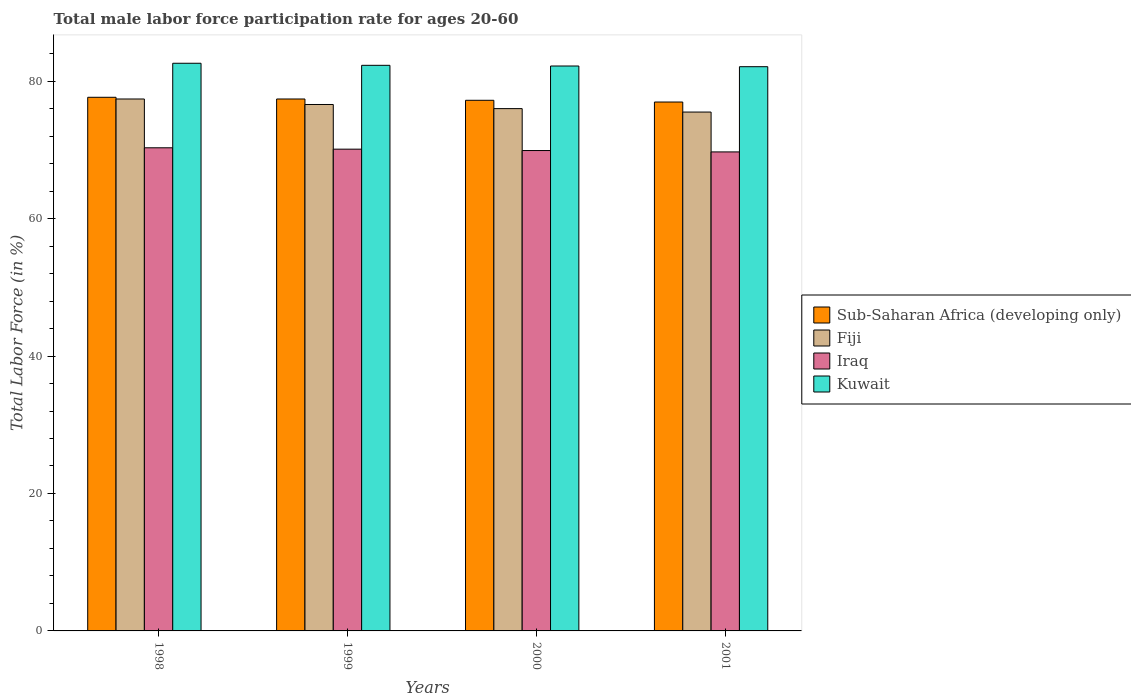How many groups of bars are there?
Your answer should be very brief. 4. How many bars are there on the 4th tick from the left?
Provide a short and direct response. 4. What is the male labor force participation rate in Kuwait in 1999?
Offer a terse response. 82.3. Across all years, what is the maximum male labor force participation rate in Iraq?
Offer a terse response. 70.3. Across all years, what is the minimum male labor force participation rate in Iraq?
Keep it short and to the point. 69.7. In which year was the male labor force participation rate in Fiji maximum?
Offer a terse response. 1998. In which year was the male labor force participation rate in Kuwait minimum?
Your response must be concise. 2001. What is the total male labor force participation rate in Kuwait in the graph?
Ensure brevity in your answer.  329.2. What is the difference between the male labor force participation rate in Iraq in 1998 and that in 1999?
Give a very brief answer. 0.2. What is the difference between the male labor force participation rate in Iraq in 2000 and the male labor force participation rate in Fiji in 1998?
Your answer should be very brief. -7.5. What is the average male labor force participation rate in Sub-Saharan Africa (developing only) per year?
Provide a succinct answer. 77.31. In the year 1998, what is the difference between the male labor force participation rate in Sub-Saharan Africa (developing only) and male labor force participation rate in Kuwait?
Your answer should be compact. -4.95. What is the ratio of the male labor force participation rate in Fiji in 1999 to that in 2001?
Your answer should be compact. 1.01. Is the male labor force participation rate in Fiji in 1999 less than that in 2001?
Your answer should be very brief. No. What is the difference between the highest and the second highest male labor force participation rate in Sub-Saharan Africa (developing only)?
Ensure brevity in your answer.  0.25. What is the difference between the highest and the lowest male labor force participation rate in Fiji?
Your answer should be compact. 1.9. Is the sum of the male labor force participation rate in Iraq in 2000 and 2001 greater than the maximum male labor force participation rate in Fiji across all years?
Your response must be concise. Yes. What does the 2nd bar from the left in 2001 represents?
Offer a very short reply. Fiji. What does the 2nd bar from the right in 2001 represents?
Ensure brevity in your answer.  Iraq. How many bars are there?
Provide a short and direct response. 16. What is the difference between two consecutive major ticks on the Y-axis?
Your answer should be compact. 20. Does the graph contain any zero values?
Provide a short and direct response. No. Does the graph contain grids?
Make the answer very short. No. Where does the legend appear in the graph?
Make the answer very short. Center right. How are the legend labels stacked?
Offer a very short reply. Vertical. What is the title of the graph?
Offer a terse response. Total male labor force participation rate for ages 20-60. Does "Caribbean small states" appear as one of the legend labels in the graph?
Your answer should be compact. No. What is the label or title of the X-axis?
Make the answer very short. Years. What is the label or title of the Y-axis?
Provide a short and direct response. Total Labor Force (in %). What is the Total Labor Force (in %) in Sub-Saharan Africa (developing only) in 1998?
Offer a terse response. 77.65. What is the Total Labor Force (in %) of Fiji in 1998?
Provide a short and direct response. 77.4. What is the Total Labor Force (in %) of Iraq in 1998?
Provide a short and direct response. 70.3. What is the Total Labor Force (in %) of Kuwait in 1998?
Your answer should be compact. 82.6. What is the Total Labor Force (in %) of Sub-Saharan Africa (developing only) in 1999?
Provide a short and direct response. 77.4. What is the Total Labor Force (in %) of Fiji in 1999?
Provide a succinct answer. 76.6. What is the Total Labor Force (in %) in Iraq in 1999?
Keep it short and to the point. 70.1. What is the Total Labor Force (in %) of Kuwait in 1999?
Make the answer very short. 82.3. What is the Total Labor Force (in %) of Sub-Saharan Africa (developing only) in 2000?
Provide a succinct answer. 77.21. What is the Total Labor Force (in %) in Fiji in 2000?
Give a very brief answer. 76. What is the Total Labor Force (in %) of Iraq in 2000?
Make the answer very short. 69.9. What is the Total Labor Force (in %) of Kuwait in 2000?
Your answer should be compact. 82.2. What is the Total Labor Force (in %) in Sub-Saharan Africa (developing only) in 2001?
Ensure brevity in your answer.  76.96. What is the Total Labor Force (in %) in Fiji in 2001?
Your response must be concise. 75.5. What is the Total Labor Force (in %) of Iraq in 2001?
Offer a very short reply. 69.7. What is the Total Labor Force (in %) of Kuwait in 2001?
Offer a terse response. 82.1. Across all years, what is the maximum Total Labor Force (in %) of Sub-Saharan Africa (developing only)?
Your answer should be compact. 77.65. Across all years, what is the maximum Total Labor Force (in %) of Fiji?
Offer a very short reply. 77.4. Across all years, what is the maximum Total Labor Force (in %) in Iraq?
Your answer should be very brief. 70.3. Across all years, what is the maximum Total Labor Force (in %) of Kuwait?
Offer a terse response. 82.6. Across all years, what is the minimum Total Labor Force (in %) in Sub-Saharan Africa (developing only)?
Your answer should be very brief. 76.96. Across all years, what is the minimum Total Labor Force (in %) of Fiji?
Give a very brief answer. 75.5. Across all years, what is the minimum Total Labor Force (in %) of Iraq?
Give a very brief answer. 69.7. Across all years, what is the minimum Total Labor Force (in %) of Kuwait?
Offer a terse response. 82.1. What is the total Total Labor Force (in %) in Sub-Saharan Africa (developing only) in the graph?
Offer a terse response. 309.22. What is the total Total Labor Force (in %) in Fiji in the graph?
Your response must be concise. 305.5. What is the total Total Labor Force (in %) of Iraq in the graph?
Provide a short and direct response. 280. What is the total Total Labor Force (in %) in Kuwait in the graph?
Your answer should be very brief. 329.2. What is the difference between the Total Labor Force (in %) of Sub-Saharan Africa (developing only) in 1998 and that in 1999?
Provide a succinct answer. 0.25. What is the difference between the Total Labor Force (in %) in Iraq in 1998 and that in 1999?
Make the answer very short. 0.2. What is the difference between the Total Labor Force (in %) in Sub-Saharan Africa (developing only) in 1998 and that in 2000?
Make the answer very short. 0.44. What is the difference between the Total Labor Force (in %) in Fiji in 1998 and that in 2000?
Keep it short and to the point. 1.4. What is the difference between the Total Labor Force (in %) of Kuwait in 1998 and that in 2000?
Give a very brief answer. 0.4. What is the difference between the Total Labor Force (in %) in Sub-Saharan Africa (developing only) in 1998 and that in 2001?
Provide a succinct answer. 0.69. What is the difference between the Total Labor Force (in %) of Fiji in 1998 and that in 2001?
Offer a very short reply. 1.9. What is the difference between the Total Labor Force (in %) of Sub-Saharan Africa (developing only) in 1999 and that in 2000?
Provide a short and direct response. 0.19. What is the difference between the Total Labor Force (in %) of Fiji in 1999 and that in 2000?
Your response must be concise. 0.6. What is the difference between the Total Labor Force (in %) in Kuwait in 1999 and that in 2000?
Provide a succinct answer. 0.1. What is the difference between the Total Labor Force (in %) in Sub-Saharan Africa (developing only) in 1999 and that in 2001?
Give a very brief answer. 0.44. What is the difference between the Total Labor Force (in %) in Fiji in 1999 and that in 2001?
Offer a terse response. 1.1. What is the difference between the Total Labor Force (in %) of Kuwait in 1999 and that in 2001?
Provide a short and direct response. 0.2. What is the difference between the Total Labor Force (in %) in Sub-Saharan Africa (developing only) in 2000 and that in 2001?
Keep it short and to the point. 0.25. What is the difference between the Total Labor Force (in %) of Sub-Saharan Africa (developing only) in 1998 and the Total Labor Force (in %) of Fiji in 1999?
Provide a succinct answer. 1.05. What is the difference between the Total Labor Force (in %) in Sub-Saharan Africa (developing only) in 1998 and the Total Labor Force (in %) in Iraq in 1999?
Ensure brevity in your answer.  7.55. What is the difference between the Total Labor Force (in %) of Sub-Saharan Africa (developing only) in 1998 and the Total Labor Force (in %) of Kuwait in 1999?
Your answer should be very brief. -4.65. What is the difference between the Total Labor Force (in %) of Fiji in 1998 and the Total Labor Force (in %) of Iraq in 1999?
Provide a succinct answer. 7.3. What is the difference between the Total Labor Force (in %) of Iraq in 1998 and the Total Labor Force (in %) of Kuwait in 1999?
Make the answer very short. -12. What is the difference between the Total Labor Force (in %) of Sub-Saharan Africa (developing only) in 1998 and the Total Labor Force (in %) of Fiji in 2000?
Provide a succinct answer. 1.65. What is the difference between the Total Labor Force (in %) in Sub-Saharan Africa (developing only) in 1998 and the Total Labor Force (in %) in Iraq in 2000?
Make the answer very short. 7.75. What is the difference between the Total Labor Force (in %) of Sub-Saharan Africa (developing only) in 1998 and the Total Labor Force (in %) of Kuwait in 2000?
Keep it short and to the point. -4.55. What is the difference between the Total Labor Force (in %) of Fiji in 1998 and the Total Labor Force (in %) of Iraq in 2000?
Offer a very short reply. 7.5. What is the difference between the Total Labor Force (in %) in Sub-Saharan Africa (developing only) in 1998 and the Total Labor Force (in %) in Fiji in 2001?
Your answer should be compact. 2.15. What is the difference between the Total Labor Force (in %) of Sub-Saharan Africa (developing only) in 1998 and the Total Labor Force (in %) of Iraq in 2001?
Ensure brevity in your answer.  7.95. What is the difference between the Total Labor Force (in %) of Sub-Saharan Africa (developing only) in 1998 and the Total Labor Force (in %) of Kuwait in 2001?
Your response must be concise. -4.45. What is the difference between the Total Labor Force (in %) in Fiji in 1998 and the Total Labor Force (in %) in Iraq in 2001?
Keep it short and to the point. 7.7. What is the difference between the Total Labor Force (in %) in Fiji in 1998 and the Total Labor Force (in %) in Kuwait in 2001?
Your response must be concise. -4.7. What is the difference between the Total Labor Force (in %) of Sub-Saharan Africa (developing only) in 1999 and the Total Labor Force (in %) of Fiji in 2000?
Your answer should be compact. 1.4. What is the difference between the Total Labor Force (in %) of Sub-Saharan Africa (developing only) in 1999 and the Total Labor Force (in %) of Iraq in 2000?
Offer a terse response. 7.5. What is the difference between the Total Labor Force (in %) in Sub-Saharan Africa (developing only) in 1999 and the Total Labor Force (in %) in Kuwait in 2000?
Offer a very short reply. -4.8. What is the difference between the Total Labor Force (in %) of Fiji in 1999 and the Total Labor Force (in %) of Iraq in 2000?
Give a very brief answer. 6.7. What is the difference between the Total Labor Force (in %) in Iraq in 1999 and the Total Labor Force (in %) in Kuwait in 2000?
Offer a terse response. -12.1. What is the difference between the Total Labor Force (in %) in Sub-Saharan Africa (developing only) in 1999 and the Total Labor Force (in %) in Fiji in 2001?
Make the answer very short. 1.9. What is the difference between the Total Labor Force (in %) of Sub-Saharan Africa (developing only) in 1999 and the Total Labor Force (in %) of Iraq in 2001?
Keep it short and to the point. 7.7. What is the difference between the Total Labor Force (in %) of Sub-Saharan Africa (developing only) in 1999 and the Total Labor Force (in %) of Kuwait in 2001?
Ensure brevity in your answer.  -4.7. What is the difference between the Total Labor Force (in %) in Fiji in 1999 and the Total Labor Force (in %) in Iraq in 2001?
Provide a short and direct response. 6.9. What is the difference between the Total Labor Force (in %) of Iraq in 1999 and the Total Labor Force (in %) of Kuwait in 2001?
Your response must be concise. -12. What is the difference between the Total Labor Force (in %) of Sub-Saharan Africa (developing only) in 2000 and the Total Labor Force (in %) of Fiji in 2001?
Ensure brevity in your answer.  1.71. What is the difference between the Total Labor Force (in %) in Sub-Saharan Africa (developing only) in 2000 and the Total Labor Force (in %) in Iraq in 2001?
Keep it short and to the point. 7.51. What is the difference between the Total Labor Force (in %) in Sub-Saharan Africa (developing only) in 2000 and the Total Labor Force (in %) in Kuwait in 2001?
Provide a short and direct response. -4.89. What is the average Total Labor Force (in %) of Sub-Saharan Africa (developing only) per year?
Keep it short and to the point. 77.31. What is the average Total Labor Force (in %) of Fiji per year?
Keep it short and to the point. 76.38. What is the average Total Labor Force (in %) in Kuwait per year?
Offer a very short reply. 82.3. In the year 1998, what is the difference between the Total Labor Force (in %) of Sub-Saharan Africa (developing only) and Total Labor Force (in %) of Fiji?
Provide a succinct answer. 0.25. In the year 1998, what is the difference between the Total Labor Force (in %) of Sub-Saharan Africa (developing only) and Total Labor Force (in %) of Iraq?
Your answer should be very brief. 7.35. In the year 1998, what is the difference between the Total Labor Force (in %) in Sub-Saharan Africa (developing only) and Total Labor Force (in %) in Kuwait?
Keep it short and to the point. -4.95. In the year 1998, what is the difference between the Total Labor Force (in %) in Fiji and Total Labor Force (in %) in Iraq?
Offer a terse response. 7.1. In the year 1998, what is the difference between the Total Labor Force (in %) in Fiji and Total Labor Force (in %) in Kuwait?
Offer a terse response. -5.2. In the year 1998, what is the difference between the Total Labor Force (in %) of Iraq and Total Labor Force (in %) of Kuwait?
Give a very brief answer. -12.3. In the year 1999, what is the difference between the Total Labor Force (in %) of Sub-Saharan Africa (developing only) and Total Labor Force (in %) of Fiji?
Provide a short and direct response. 0.8. In the year 1999, what is the difference between the Total Labor Force (in %) in Sub-Saharan Africa (developing only) and Total Labor Force (in %) in Iraq?
Provide a short and direct response. 7.3. In the year 1999, what is the difference between the Total Labor Force (in %) of Sub-Saharan Africa (developing only) and Total Labor Force (in %) of Kuwait?
Your response must be concise. -4.9. In the year 1999, what is the difference between the Total Labor Force (in %) in Fiji and Total Labor Force (in %) in Iraq?
Make the answer very short. 6.5. In the year 2000, what is the difference between the Total Labor Force (in %) of Sub-Saharan Africa (developing only) and Total Labor Force (in %) of Fiji?
Offer a terse response. 1.21. In the year 2000, what is the difference between the Total Labor Force (in %) in Sub-Saharan Africa (developing only) and Total Labor Force (in %) in Iraq?
Ensure brevity in your answer.  7.31. In the year 2000, what is the difference between the Total Labor Force (in %) of Sub-Saharan Africa (developing only) and Total Labor Force (in %) of Kuwait?
Your answer should be compact. -4.99. In the year 2000, what is the difference between the Total Labor Force (in %) of Iraq and Total Labor Force (in %) of Kuwait?
Make the answer very short. -12.3. In the year 2001, what is the difference between the Total Labor Force (in %) of Sub-Saharan Africa (developing only) and Total Labor Force (in %) of Fiji?
Give a very brief answer. 1.46. In the year 2001, what is the difference between the Total Labor Force (in %) in Sub-Saharan Africa (developing only) and Total Labor Force (in %) in Iraq?
Offer a terse response. 7.26. In the year 2001, what is the difference between the Total Labor Force (in %) of Sub-Saharan Africa (developing only) and Total Labor Force (in %) of Kuwait?
Give a very brief answer. -5.14. In the year 2001, what is the difference between the Total Labor Force (in %) of Fiji and Total Labor Force (in %) of Iraq?
Offer a very short reply. 5.8. What is the ratio of the Total Labor Force (in %) in Fiji in 1998 to that in 1999?
Offer a terse response. 1.01. What is the ratio of the Total Labor Force (in %) in Kuwait in 1998 to that in 1999?
Offer a very short reply. 1. What is the ratio of the Total Labor Force (in %) in Fiji in 1998 to that in 2000?
Offer a very short reply. 1.02. What is the ratio of the Total Labor Force (in %) of Kuwait in 1998 to that in 2000?
Give a very brief answer. 1. What is the ratio of the Total Labor Force (in %) of Sub-Saharan Africa (developing only) in 1998 to that in 2001?
Make the answer very short. 1.01. What is the ratio of the Total Labor Force (in %) in Fiji in 1998 to that in 2001?
Keep it short and to the point. 1.03. What is the ratio of the Total Labor Force (in %) of Iraq in 1998 to that in 2001?
Keep it short and to the point. 1.01. What is the ratio of the Total Labor Force (in %) in Fiji in 1999 to that in 2000?
Make the answer very short. 1.01. What is the ratio of the Total Labor Force (in %) of Iraq in 1999 to that in 2000?
Ensure brevity in your answer.  1. What is the ratio of the Total Labor Force (in %) of Kuwait in 1999 to that in 2000?
Your response must be concise. 1. What is the ratio of the Total Labor Force (in %) in Fiji in 1999 to that in 2001?
Ensure brevity in your answer.  1.01. What is the ratio of the Total Labor Force (in %) of Iraq in 1999 to that in 2001?
Offer a very short reply. 1.01. What is the ratio of the Total Labor Force (in %) of Sub-Saharan Africa (developing only) in 2000 to that in 2001?
Offer a very short reply. 1. What is the ratio of the Total Labor Force (in %) in Fiji in 2000 to that in 2001?
Ensure brevity in your answer.  1.01. What is the ratio of the Total Labor Force (in %) in Iraq in 2000 to that in 2001?
Ensure brevity in your answer.  1. What is the ratio of the Total Labor Force (in %) in Kuwait in 2000 to that in 2001?
Offer a terse response. 1. What is the difference between the highest and the second highest Total Labor Force (in %) of Sub-Saharan Africa (developing only)?
Your answer should be compact. 0.25. What is the difference between the highest and the second highest Total Labor Force (in %) of Iraq?
Provide a short and direct response. 0.2. What is the difference between the highest and the second highest Total Labor Force (in %) of Kuwait?
Your answer should be very brief. 0.3. What is the difference between the highest and the lowest Total Labor Force (in %) in Sub-Saharan Africa (developing only)?
Your answer should be compact. 0.69. What is the difference between the highest and the lowest Total Labor Force (in %) in Fiji?
Make the answer very short. 1.9. What is the difference between the highest and the lowest Total Labor Force (in %) of Kuwait?
Your answer should be very brief. 0.5. 